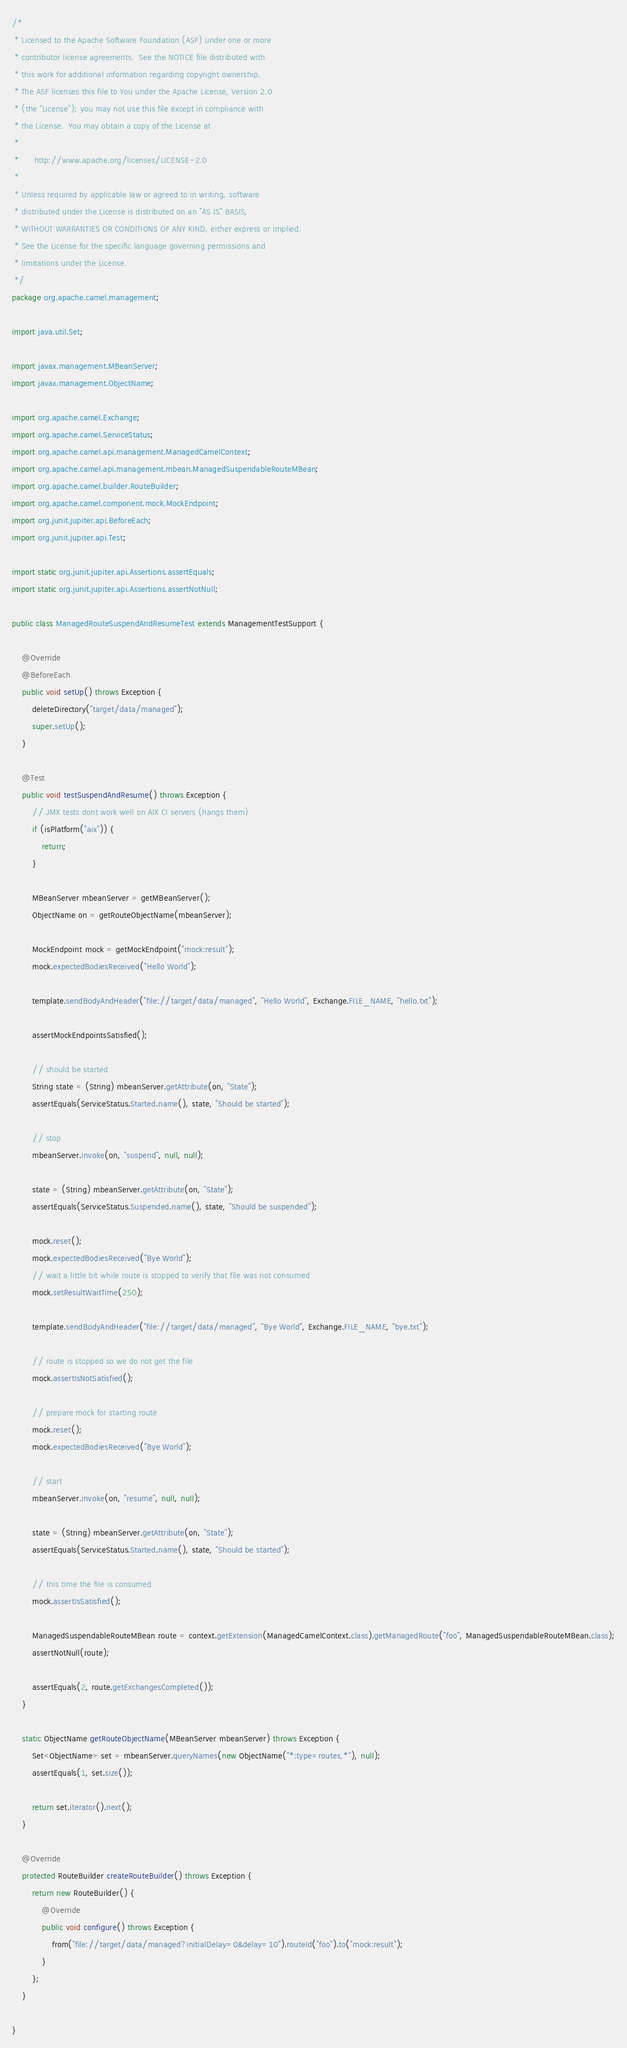<code> <loc_0><loc_0><loc_500><loc_500><_Java_>/*
 * Licensed to the Apache Software Foundation (ASF) under one or more
 * contributor license agreements.  See the NOTICE file distributed with
 * this work for additional information regarding copyright ownership.
 * The ASF licenses this file to You under the Apache License, Version 2.0
 * (the "License"); you may not use this file except in compliance with
 * the License.  You may obtain a copy of the License at
 *
 *      http://www.apache.org/licenses/LICENSE-2.0
 *
 * Unless required by applicable law or agreed to in writing, software
 * distributed under the License is distributed on an "AS IS" BASIS,
 * WITHOUT WARRANTIES OR CONDITIONS OF ANY KIND, either express or implied.
 * See the License for the specific language governing permissions and
 * limitations under the License.
 */
package org.apache.camel.management;

import java.util.Set;

import javax.management.MBeanServer;
import javax.management.ObjectName;

import org.apache.camel.Exchange;
import org.apache.camel.ServiceStatus;
import org.apache.camel.api.management.ManagedCamelContext;
import org.apache.camel.api.management.mbean.ManagedSuspendableRouteMBean;
import org.apache.camel.builder.RouteBuilder;
import org.apache.camel.component.mock.MockEndpoint;
import org.junit.jupiter.api.BeforeEach;
import org.junit.jupiter.api.Test;

import static org.junit.jupiter.api.Assertions.assertEquals;
import static org.junit.jupiter.api.Assertions.assertNotNull;

public class ManagedRouteSuspendAndResumeTest extends ManagementTestSupport {

    @Override
    @BeforeEach
    public void setUp() throws Exception {
        deleteDirectory("target/data/managed");
        super.setUp();
    }

    @Test
    public void testSuspendAndResume() throws Exception {
        // JMX tests dont work well on AIX CI servers (hangs them)
        if (isPlatform("aix")) {
            return;
        }

        MBeanServer mbeanServer = getMBeanServer();
        ObjectName on = getRouteObjectName(mbeanServer);

        MockEndpoint mock = getMockEndpoint("mock:result");
        mock.expectedBodiesReceived("Hello World");

        template.sendBodyAndHeader("file://target/data/managed", "Hello World", Exchange.FILE_NAME, "hello.txt");

        assertMockEndpointsSatisfied();

        // should be started
        String state = (String) mbeanServer.getAttribute(on, "State");
        assertEquals(ServiceStatus.Started.name(), state, "Should be started");

        // stop
        mbeanServer.invoke(on, "suspend", null, null);

        state = (String) mbeanServer.getAttribute(on, "State");
        assertEquals(ServiceStatus.Suspended.name(), state, "Should be suspended");

        mock.reset();
        mock.expectedBodiesReceived("Bye World");
        // wait a little bit while route is stopped to verify that file was not consumed
        mock.setResultWaitTime(250);

        template.sendBodyAndHeader("file://target/data/managed", "Bye World", Exchange.FILE_NAME, "bye.txt");

        // route is stopped so we do not get the file
        mock.assertIsNotSatisfied();

        // prepare mock for starting route
        mock.reset();
        mock.expectedBodiesReceived("Bye World");

        // start
        mbeanServer.invoke(on, "resume", null, null);

        state = (String) mbeanServer.getAttribute(on, "State");
        assertEquals(ServiceStatus.Started.name(), state, "Should be started");

        // this time the file is consumed
        mock.assertIsSatisfied();

        ManagedSuspendableRouteMBean route = context.getExtension(ManagedCamelContext.class).getManagedRoute("foo", ManagedSuspendableRouteMBean.class);
        assertNotNull(route);

        assertEquals(2, route.getExchangesCompleted());
    }

    static ObjectName getRouteObjectName(MBeanServer mbeanServer) throws Exception {
        Set<ObjectName> set = mbeanServer.queryNames(new ObjectName("*:type=routes,*"), null);
        assertEquals(1, set.size());

        return set.iterator().next();
    }

    @Override
    protected RouteBuilder createRouteBuilder() throws Exception {
        return new RouteBuilder() {
            @Override
            public void configure() throws Exception {
                from("file://target/data/managed?initialDelay=0&delay=10").routeId("foo").to("mock:result");
            }
        };
    }

}
</code> 